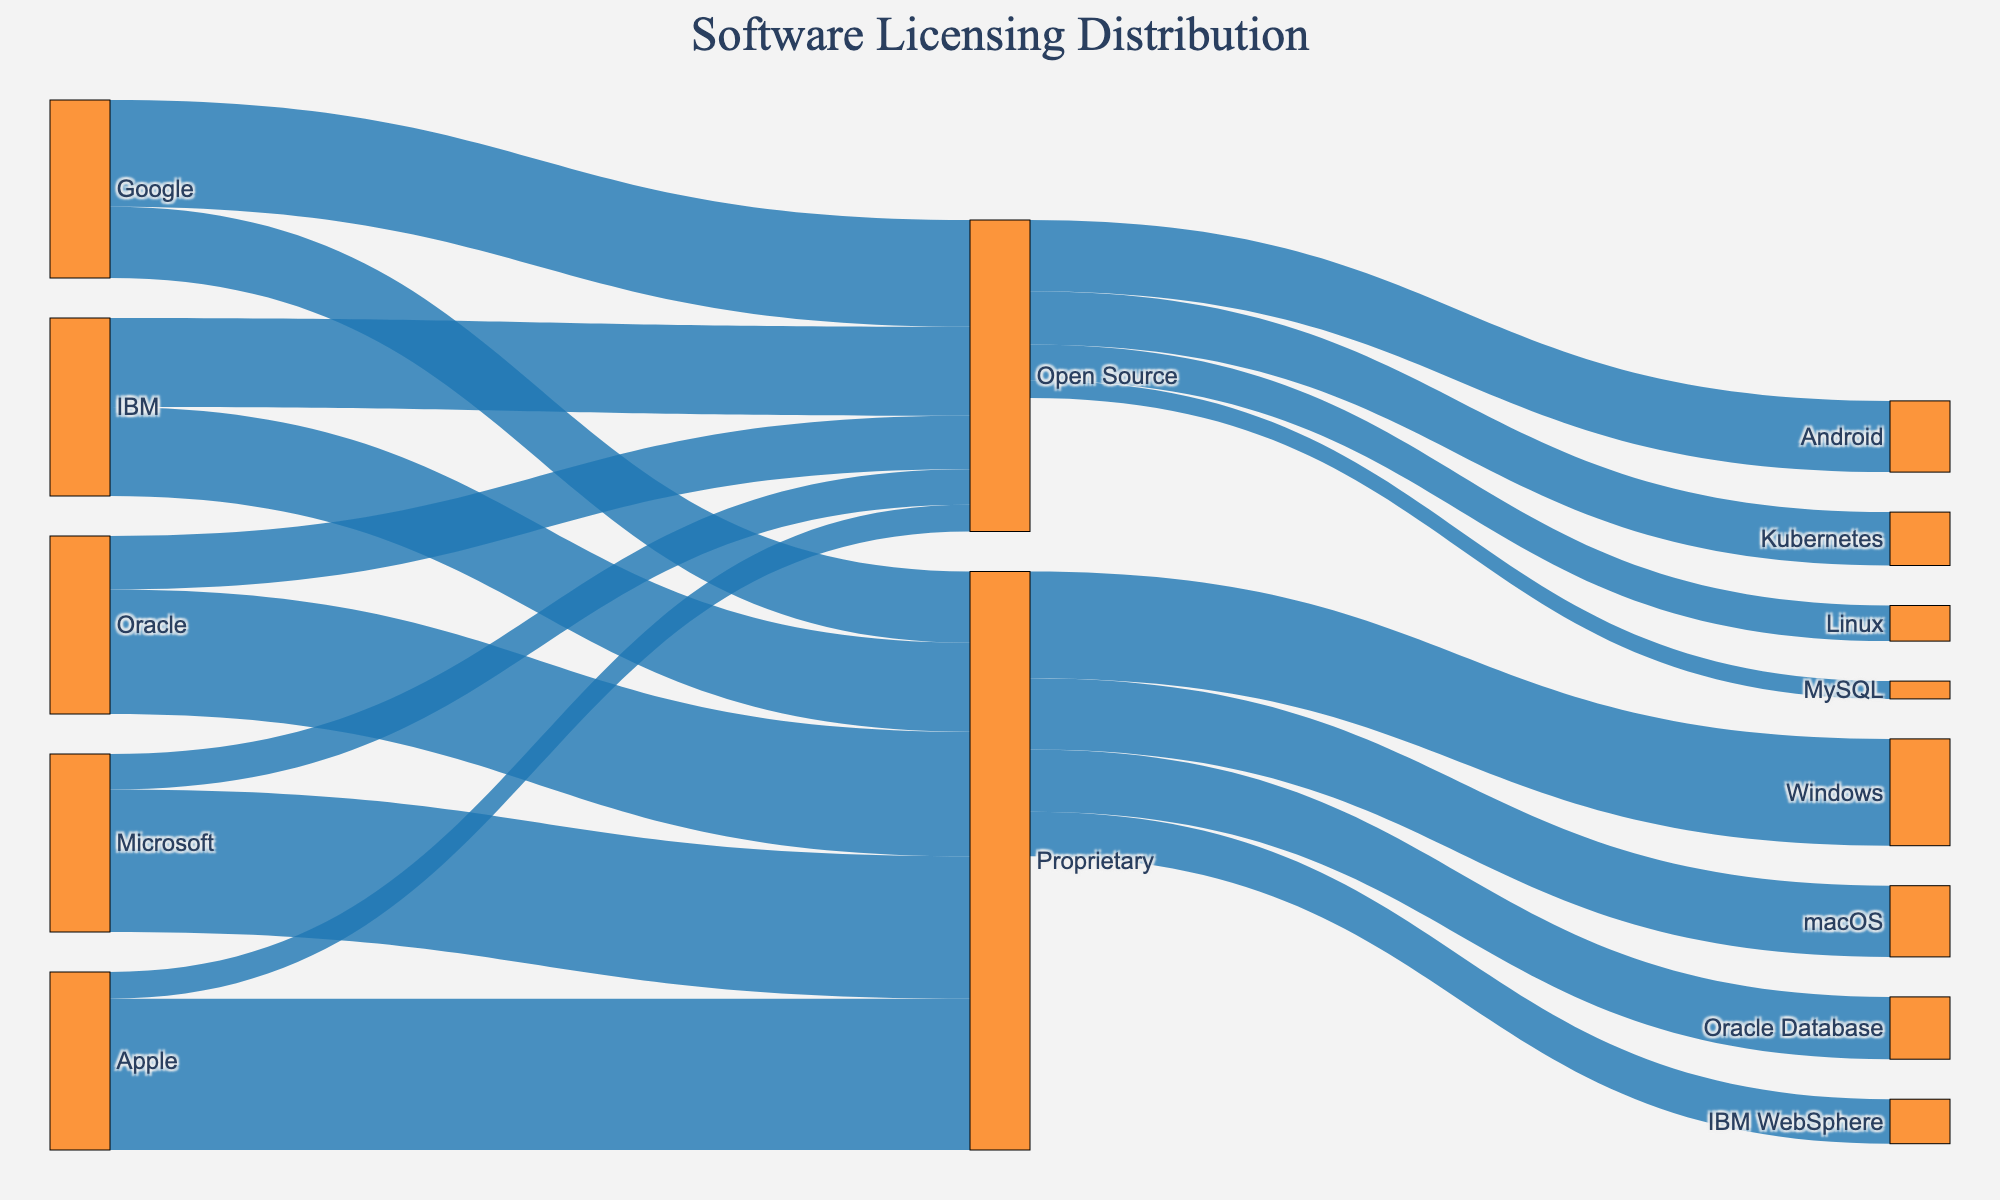What's the title of the diagram? You can find the title at the top of the diagram, in larger, bold text.
Answer: Software Licensing Distribution How many tech companies are displayed in the Sankey Diagram? Count the unique sources in the data, which are Microsoft, Apple, Google, IBM, and Oracle.
Answer: 5 What is the percentage of open-source software contributions made by Apple? Identify Apple in the diagram and find the link labeled "Open Source," which shows a contribution of 15%.
Answer: 15% Which company has the largest proportion of proprietary software? Compare the proprietary software values for all companies (Microsoft: 80, Apple: 85, Google: 40, IBM: 50, Oracle: 70). Apple has the highest value at 85.
Answer: Apple What software product has the highest representation in the open-source segment? Look at the targets under the "Open Source" category. Android has the highest value (40).
Answer: Android How many software products are represented in the proprietary segment? Observe the targets under the "Proprietary" category: Windows, macOS, Oracle Database, and IBM WebSphere. Count them.
Answer: 4 Compare the contributions to open-source software by Google and Microsoft. Which one is higher and by how much? Google's contribution to open source is 60, and Microsoft's is 20. Subtract 20 from 60.
Answer: Google by 40 What's the total value of contributions made to proprietary software by Microsoft and Apple combined? Sum Microsoft's (80) and Apple's (85) contributions to the proprietary segment. 80 + 85 = 165
Answer: 165 What is the combined total value of all open-source software contributions? Sum up all open-source values: 20 (Microsoft) + 15 (Apple) + 60 (Google) + 50 (IBM) + 30 (Oracle). The total is 20 + 15 + 60 + 50 + 30 = 175.
Answer: 175 What's the proportion of open-source contributions for IBM compared to its total contributions? IBM's total contributions are 50 (Proprietary) + 50 (Open Source). The proportion is 50 (Open Source) / 100 (Total) = 0.5 or 50%.
Answer: 50% 